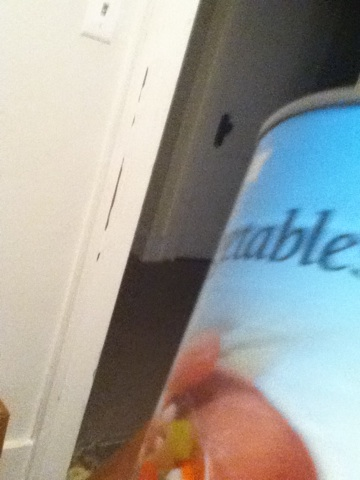How can canned vegetables impact meal preparation? Canned vegetables can significantly simplify meal preparation by reducing cooking time. They are pre-cooked and ready to eat, which means you can spend less time washing, peeling, and chopping. This makes them an excellent option for quick and easy meals, allowing you to add vegetables to your diet even when you're short on time. Are there any downsides to using canned vegetables? While canned vegetables are convenient, they may have some downsides. They can sometimes contain added salt or preservatives, which might not be ideal for those on a low-sodium diet. Additionally, the canning process can lead to a loss of some water-soluble vitamins like Vitamin C. However, they are still a nutritious option, especially when fresh vegetables are not available. 